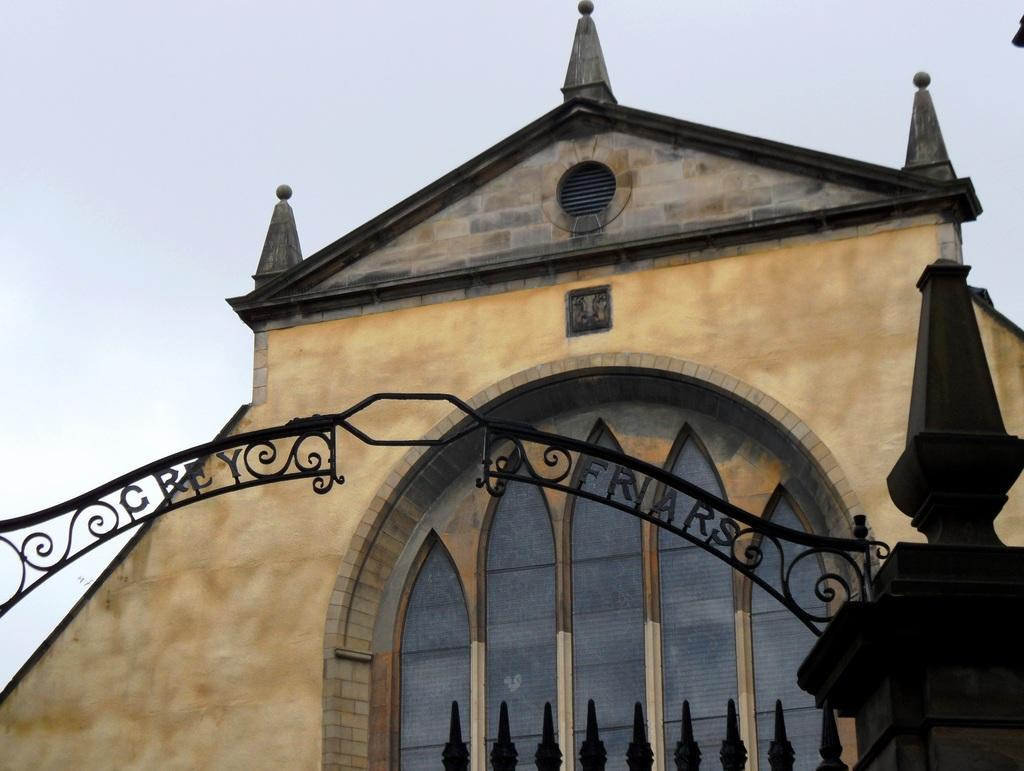What structure is located in the middle of the image? There is an arch in the middle of the image. What type of building can be seen in the background of the image? There is a building with glass windows in the background of the image. What type of land is visible in the image? There is no specific type of land visible in the image; it only features an arch and a building in the background. 